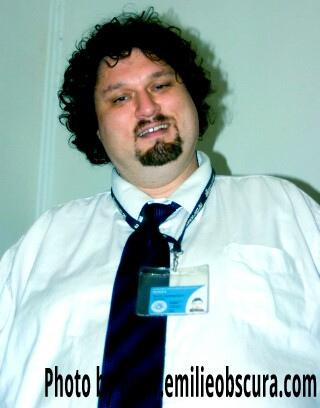Question: where was the photo taken?
Choices:
A. Behind the man.
B. Behind the woman.
C. In front of the woman.
D. In front of man.
Answer with the letter. Answer: D Question: what is blue and black?
Choices:
A. A tie.
B. The shirt.
C. The cap.
D. The eye.
Answer with the letter. Answer: A Question: who has a beard?
Choices:
A. A man.
B. Santa.
C. The dad.
D. The mom.
Answer with the letter. Answer: A Question: where is a tie?
Choices:
A. In the closet.
B. In the drawer.
C. On the floor.
D. Around man's neck.
Answer with the letter. Answer: D Question: what is white?
Choices:
A. Man's shirt.
B. Woman's shirt.
C. The pants.
D. The tie.
Answer with the letter. Answer: A Question: who has brown hair?
Choices:
A. Woman.
B. Boy.
C. Man.
D. Girl.
Answer with the letter. Answer: C Question: who has curly hair?
Choices:
A. The woman.
B. The boy.
C. The girl.
D. The man.
Answer with the letter. Answer: D 